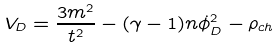<formula> <loc_0><loc_0><loc_500><loc_500>V _ { D } = \frac { 3 m ^ { 2 } } { t ^ { 2 } } - ( \gamma - 1 ) n \dot { \phi } _ { D } ^ { 2 } - \rho _ { c h }</formula> 